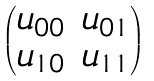<formula> <loc_0><loc_0><loc_500><loc_500>\begin{pmatrix} u _ { 0 0 } & u _ { 0 1 } \\ u _ { 1 0 } & u _ { 1 1 } \end{pmatrix}</formula> 